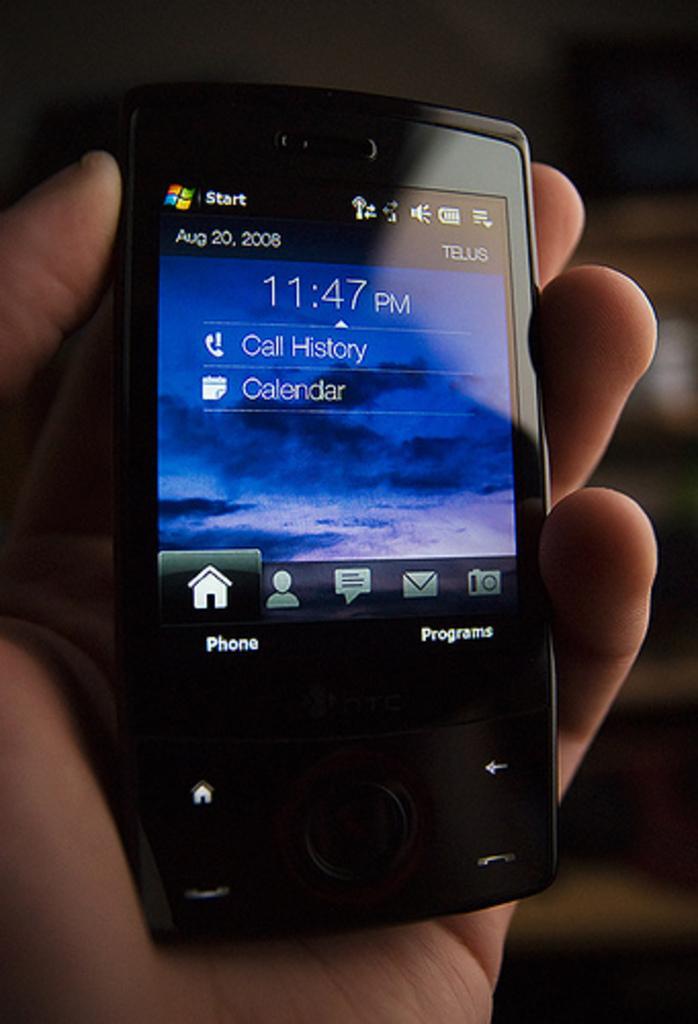In one or two sentences, can you explain what this image depicts? In the picture we can see a person hand holding a mobile phone which is black in color with a screen. 